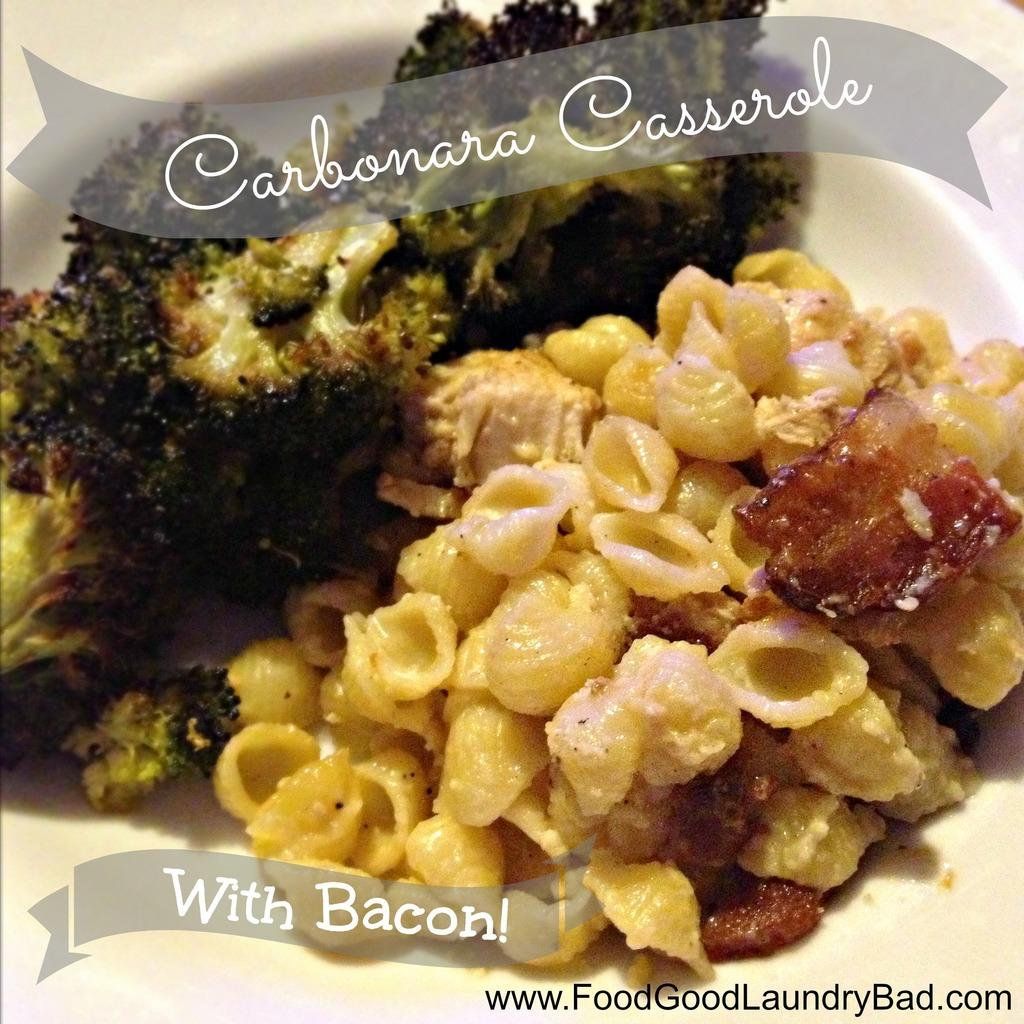What can be seen on the surface in the image? There is food placed on a surface in the image. What else is visible on the surface besides the food? There is text visible on the surface in the image. How does the zebra interact with the text on the surface in the image? There is no zebra present in the image, so it cannot interact with the text on the surface. 